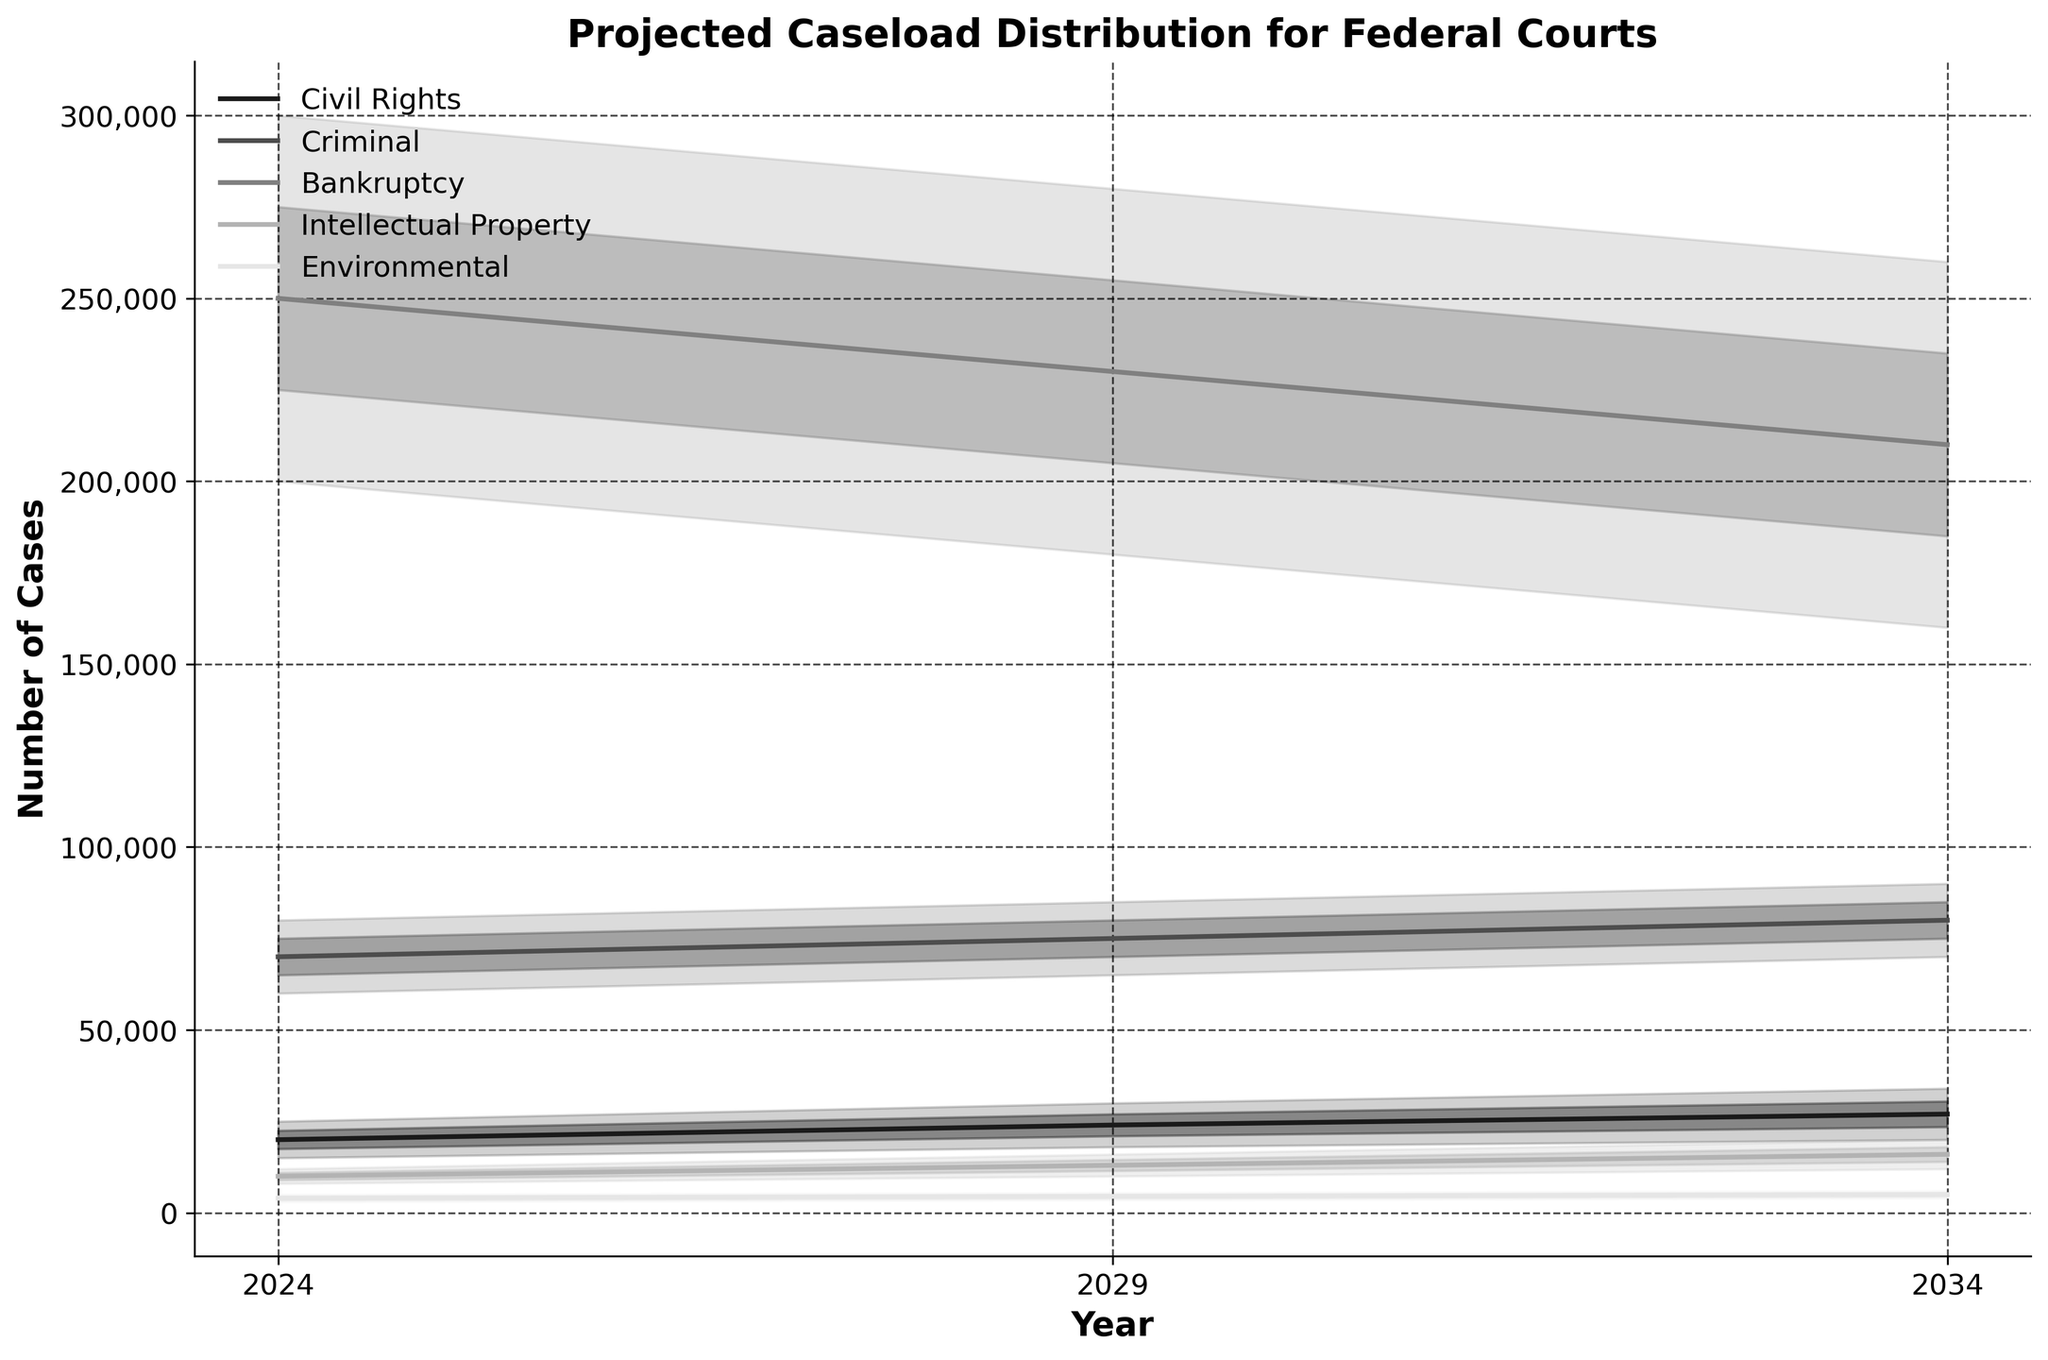What's the title of the figure? The title is typically placed at the top of the figure. It gives an overview of what the figure represents. In this case, the title can be found directly above the plot area.
Answer: Projected Caseload Distribution for Federal Courts What does the x-axis represent? The x-axis usually represents the independent variable. In this figure, it indicates time in years, which you can see labeled at regular intervals along the horizontal axis.
Answer: Year Which case type has the highest mid-estimate caseload in 2024? Look for the Mid Estimate values for each case type in 2024. Compare these values to find the highest one. Bankruptcy has the highest value at 250,000 cases.
Answer: Bankruptcy What is the range of the projected caseload for Intellectual Property cases in 2029? To find the range, look at the Low Estimate and High Estimate values for Intellectual Property in 2029. Subtract the Low Estimate from the High Estimate. In this case, it's 16,000 - 10,000.
Answer: 6,000 Between which years is the projected caseload for Civil Rights expected to increase the most? Calculate the differences in Mid Estimate caseloads between sequential years for Civil Rights. Comparison shows that the biggest increase is from 2029 to 2034 (from 24,000 to 27,000 = 3,000).
Answer: 2029 to 2034 Which case type shows the least variation in projected caseload in 2034? Variation can be observed by looking at the ranges (difference between High and Low estimates). For each case type in 2034, find the difference and compare. Environmental cases have the smallest range (6,000 - 4,000 = 2,000).
Answer: Environmental How does the projected caseload for Criminal cases in 2034 compare to the projected caseload in 2024? Compare the Mid Estimates for Criminal in 2034 and 2024. See how much the value changes. It goes from 70,000 in 2024 to 80,000 in 2034, showing an increase.
Answer: Increases by 10,000 What trends are observable across all case types from 2024 to 2034? Look at the general direction of the Mid Estimate lines across all case types. Most of them show an increasing trend, which means caseloads are generally projected to rise.
Answer: Increasing trend for most case types For Bankruptcy cases, what is the difference between the High Estimate in 2029 and the Low Estimate in 2024? Subtract the Low Estimate for Bankruptcy in 2024 from the High Estimate in 2029. The values are 280,000 - 200,000.
Answer: 80,000 How is the color used to differentiate between case types? Color coding helps distinguish different elements in a plot. Different shades of grey are used for each case type to make it easier to differentiate between them visually.
Answer: Different shades of grey Which case type has the most significant upwards trend in the Mid Estimate from 2024 to 2034? Track the Mid Estimate values for each type from 2024 to 2034 and calculate the increase. Civil Rights has a noticeable increase from 20,000 to 27,000.
Answer: Civil Rights 